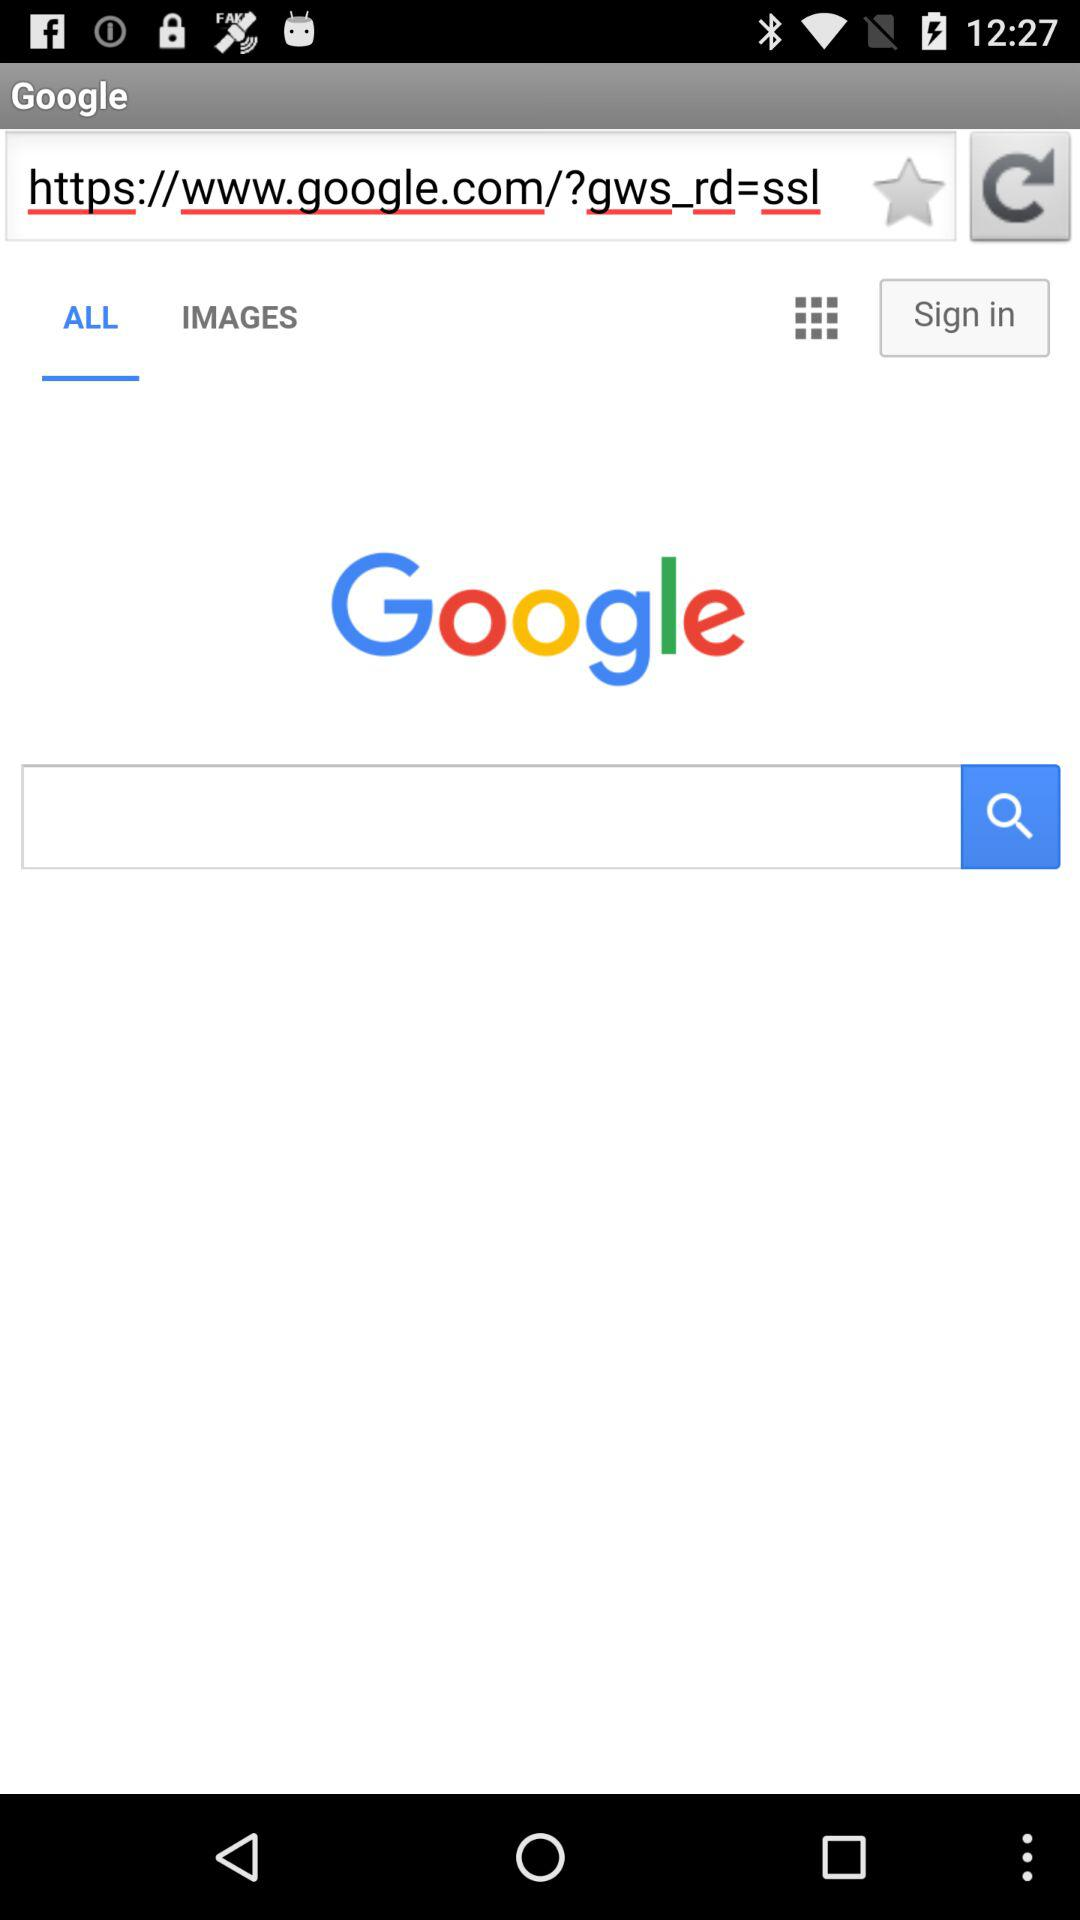Which tab is selected? The selected tab is "ALL". 